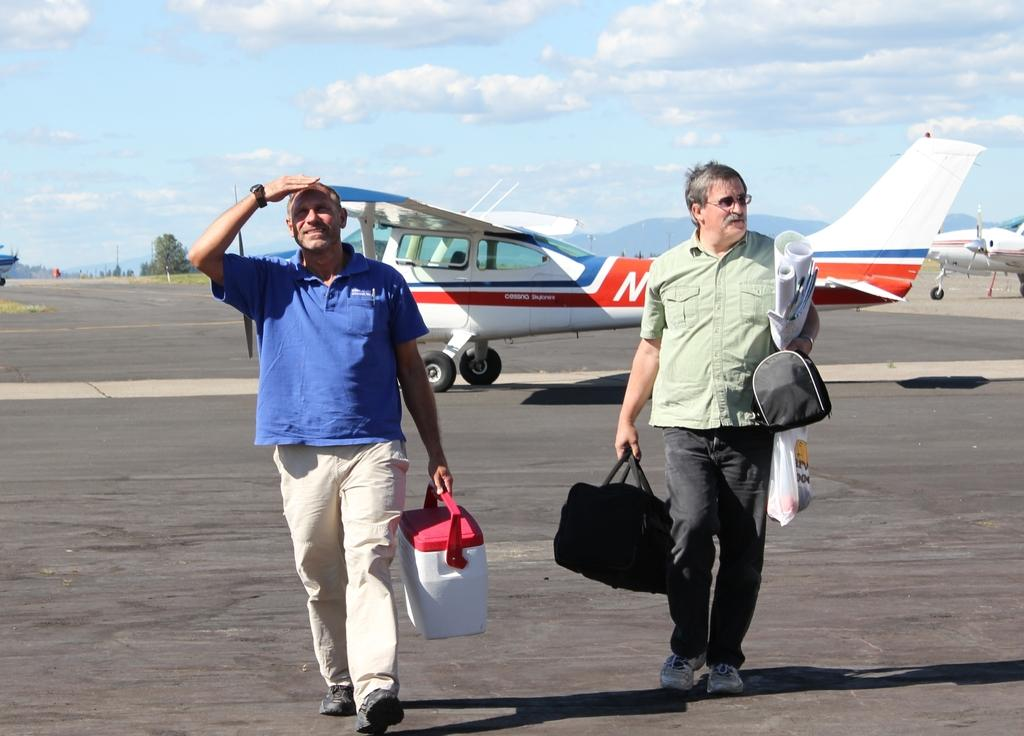How many men are in the image? There are two men in the image. What is the man on the left side holding? The man on the left side is holding a box. What is the man on the right side holding? The man on the right side is holding baggage. What can be seen in the background of the image? There are plants and trees in the background of the image. Reasoning: Let's think step by following the guidelines to produce the conversation. We start by identifying the number of men in the image, which is two. Then, we describe what each man is holding, providing specific details about the objects they are carrying. Finally, we mention the background elements, which are plants and trees. Each question is designed to elicit a specific detail about the image that is known from the provided facts. Absurd Question/Answer: What type of star can be seen in the image? There is no star visible in the image. What is the level of harmony between the two men in the image? The image does not provide any information about the relationship or harmony between the two men. 